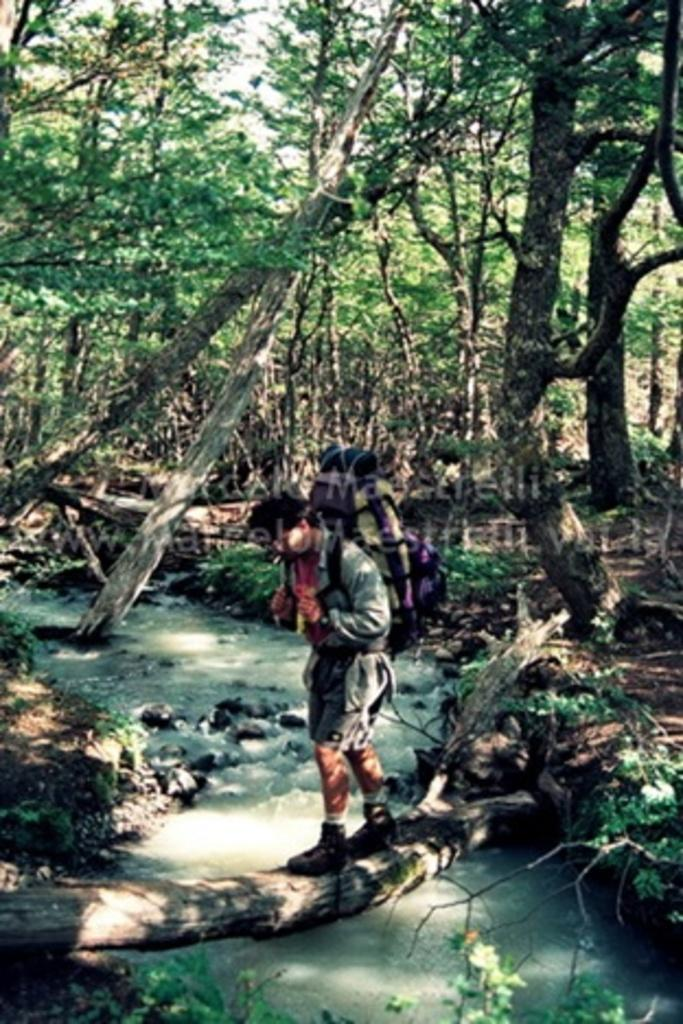What is the main subject of the image? There is a person walking in the center of the image. What is located at the bottom of the image? There is a lake at the bottom of the image. What can be seen in the background of the image? There are trees and plants in the background of the image. What type of screw is being used by the team in the image? There is no team or screw present in the image; it features a person walking near a lake with trees and plants in the background. 